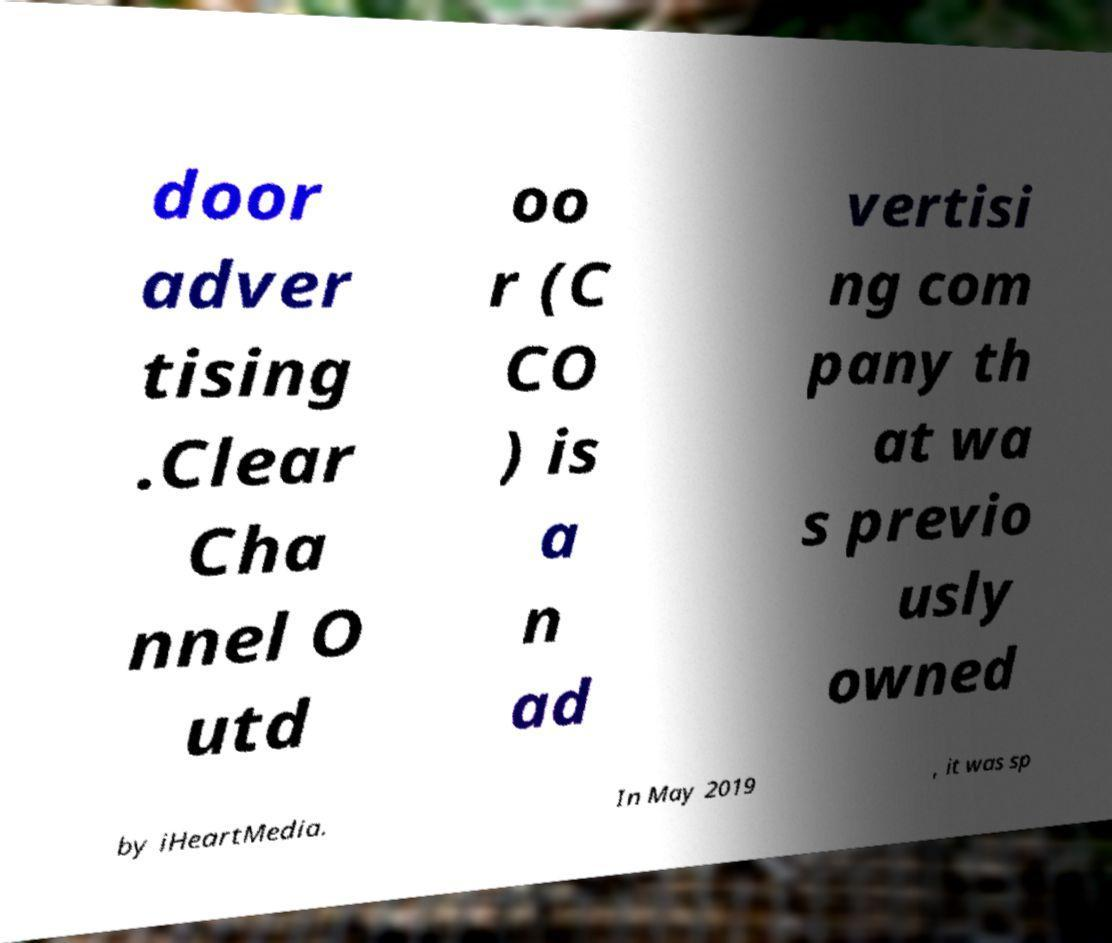What messages or text are displayed in this image? I need them in a readable, typed format. door adver tising .Clear Cha nnel O utd oo r (C CO ) is a n ad vertisi ng com pany th at wa s previo usly owned by iHeartMedia. In May 2019 , it was sp 